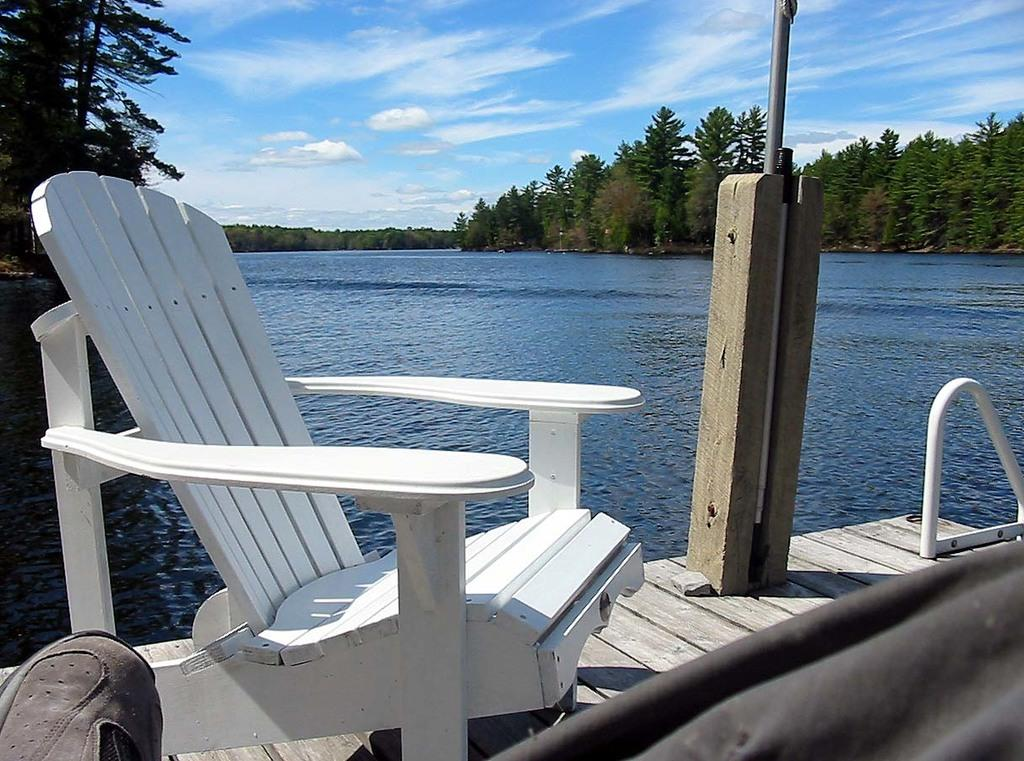What type of chair is in the image? There is a white color wooden chair in the image. What is the chair placed on? The chair is on a wooden floor. What can be seen in the background of the image? There is a pole, water (likely a river), trees, and clouds in the blue sky in the background of the image. Where is the vase located in the image? There is no vase present in the image. What type of work is the maid performing in the image? There is no maid present in the image. 